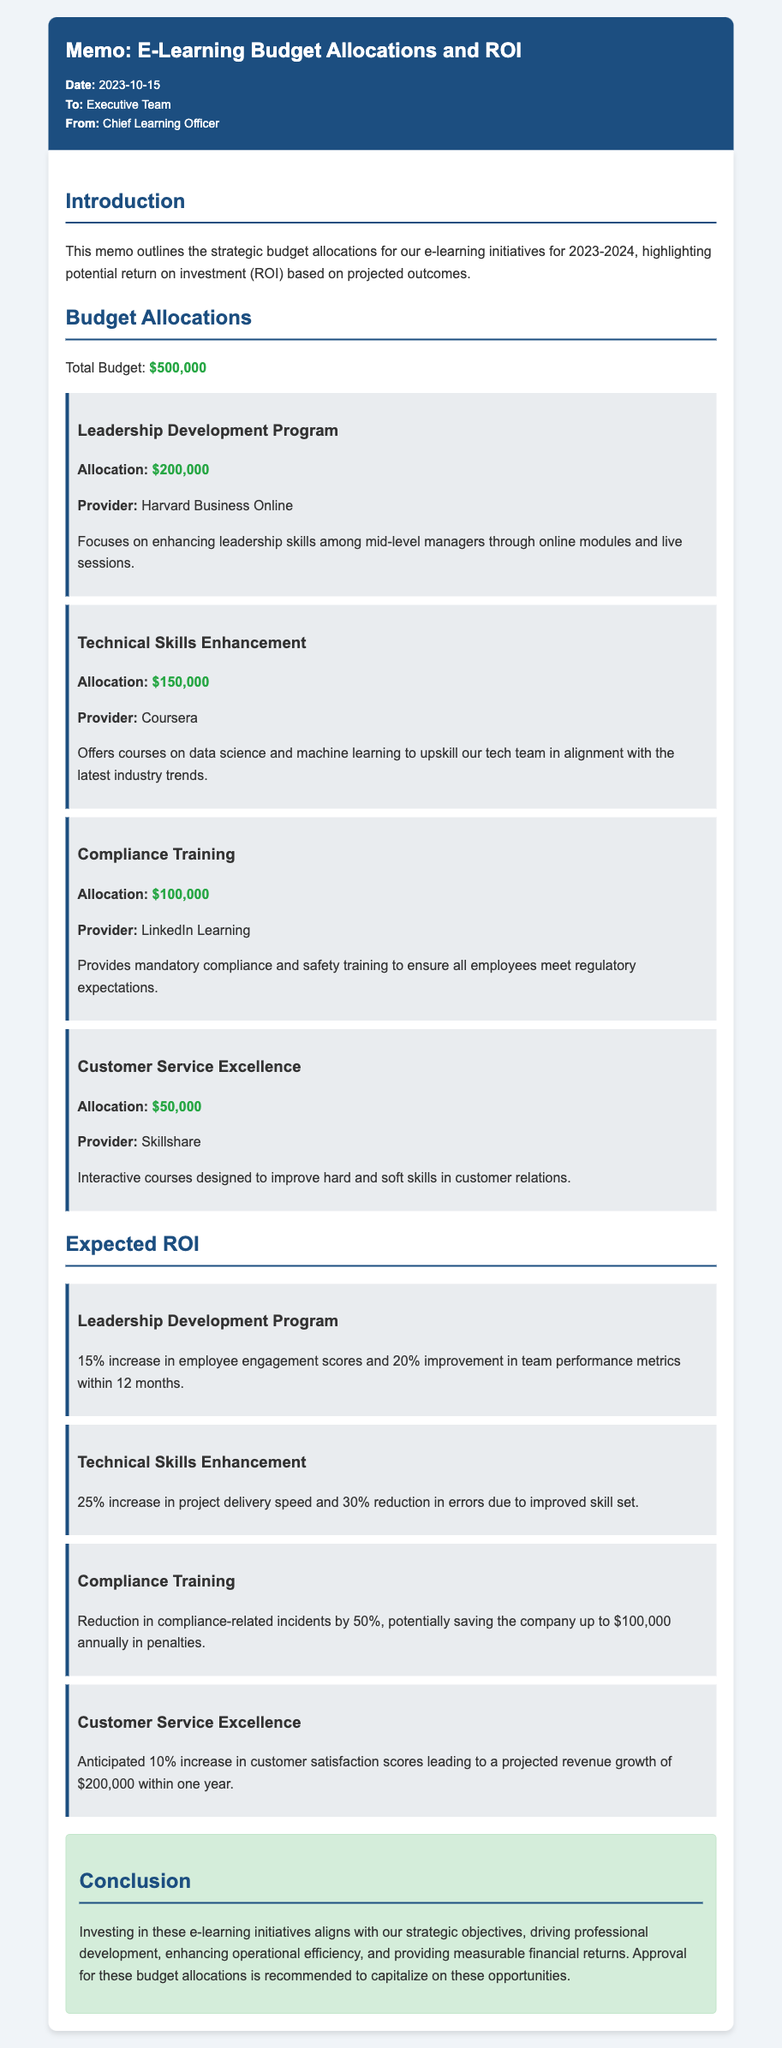what is the total budget allocated for e-learning initiatives? The total budget is specified in the document as a single amount for e-learning initiatives, which is $500,000.
Answer: $500,000 who is the provider for the Leadership Development Program? The document lists the provider specifically for the Leadership Development Program, which is Harvard Business Online.
Answer: Harvard Business Online what percentage increase in employee engagement scores is expected from the Leadership Development Program? The expected increase is mentioned directly in the ROI section for the Leadership Development Program, which is 15%.
Answer: 15% how much is allocated for Compliance Training? The document details the allocation for Compliance Training specifically, which is $100,000.
Answer: $100,000 what is the expected revenue growth from the Customer Service Excellence initiative? The projected revenue growth is explicitly mentioned for the Customer Service Excellence initiative, which is $200,000.
Answer: $200,000 what outcome is anticipated for Technical Skills Enhancement in project delivery speed? The document states that a 25% increase in project delivery speed is expected from the Technical Skills Enhancement program.
Answer: 25% what is one key benefit mentioned for Compliance Training? The document highlights a specific benefit, which is a reduction in compliance-related incidents by 50%.
Answer: 50% how much is allocated for Customer Service Excellence? The allocation for Customer Service Excellence is provided in the budget section, mentioned as $50,000.
Answer: $50,000 what is the expected improvement in team performance metrics from the Leadership Development Program? The expected improvement in team performance metrics from the Leadership Development Program is noted as 20%.
Answer: 20% what is the recommended action regarding the budget allocations? The document concludes with a recommended action regarding the budget allocations, which is to approve them.
Answer: Approve 